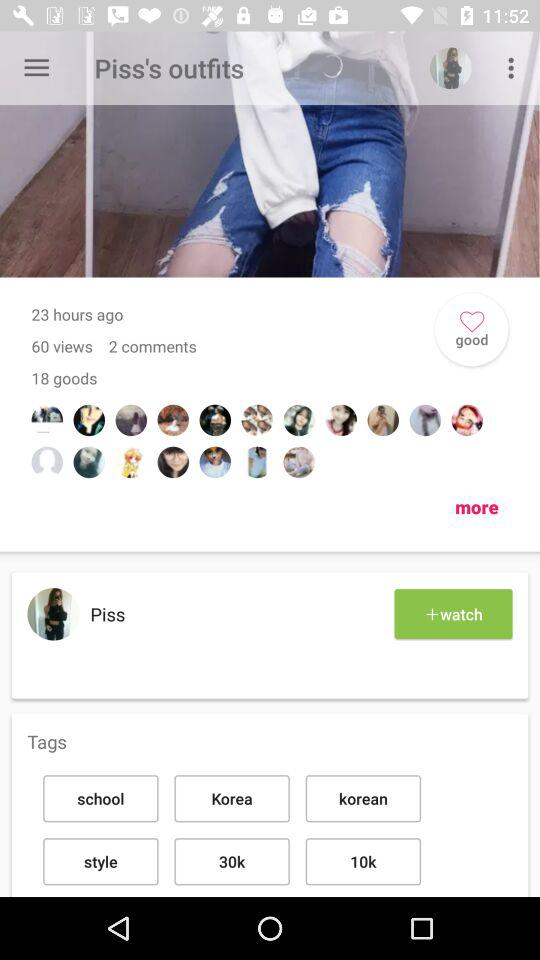What is the total number of goods shown on the screen? The total number of goods shown on the screen is 18. 